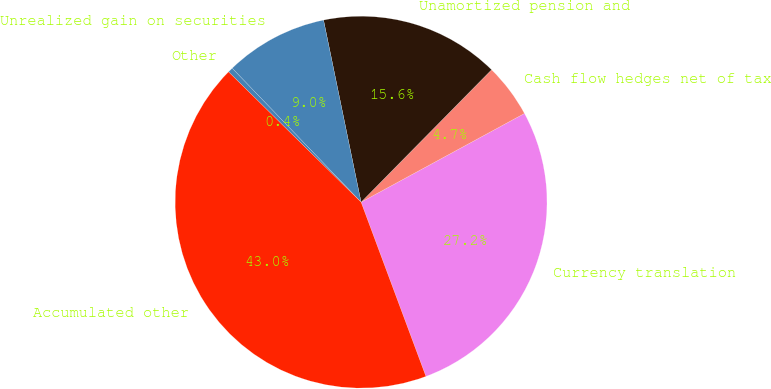Convert chart to OTSL. <chart><loc_0><loc_0><loc_500><loc_500><pie_chart><fcel>Currency translation<fcel>Cash flow hedges net of tax<fcel>Unamortized pension and<fcel>Unrealized gain on securities<fcel>Other<fcel>Accumulated other<nl><fcel>27.25%<fcel>4.7%<fcel>15.62%<fcel>8.96%<fcel>0.44%<fcel>43.04%<nl></chart> 